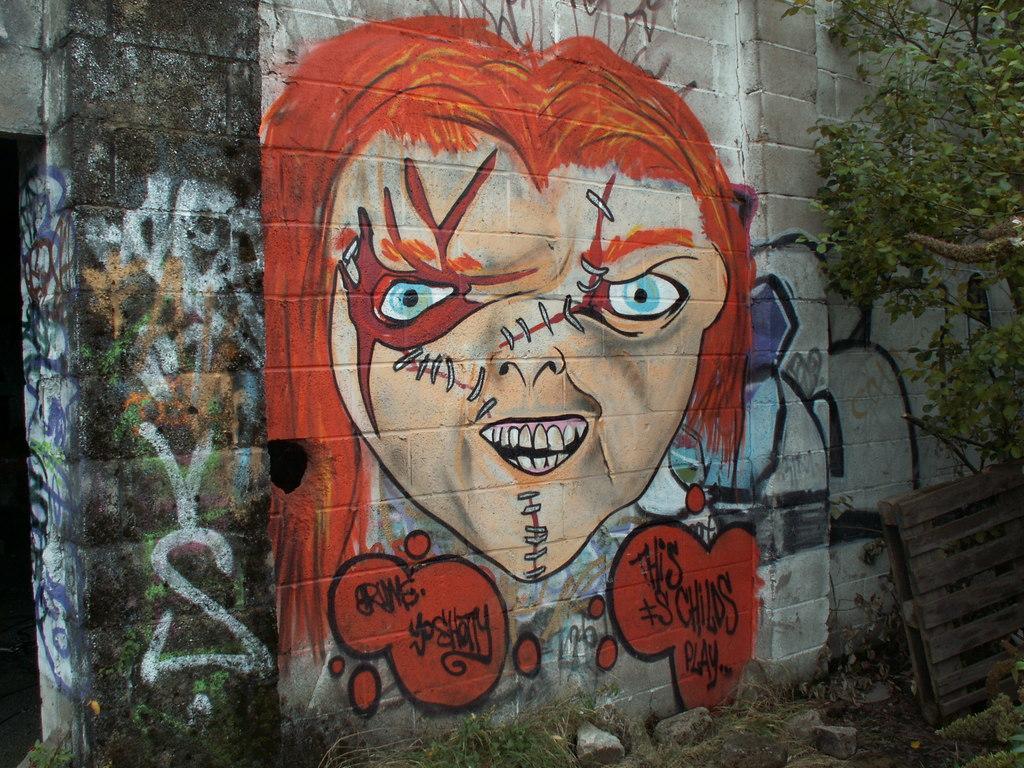Please provide a concise description of this image. In this image there is a wall. There are paintings of face and text on the wall. To the right there is tree in front of the wall. In the bottom right there is a wooden plank leaning on the wall. At the bottom there are stones and grass on the ground. 